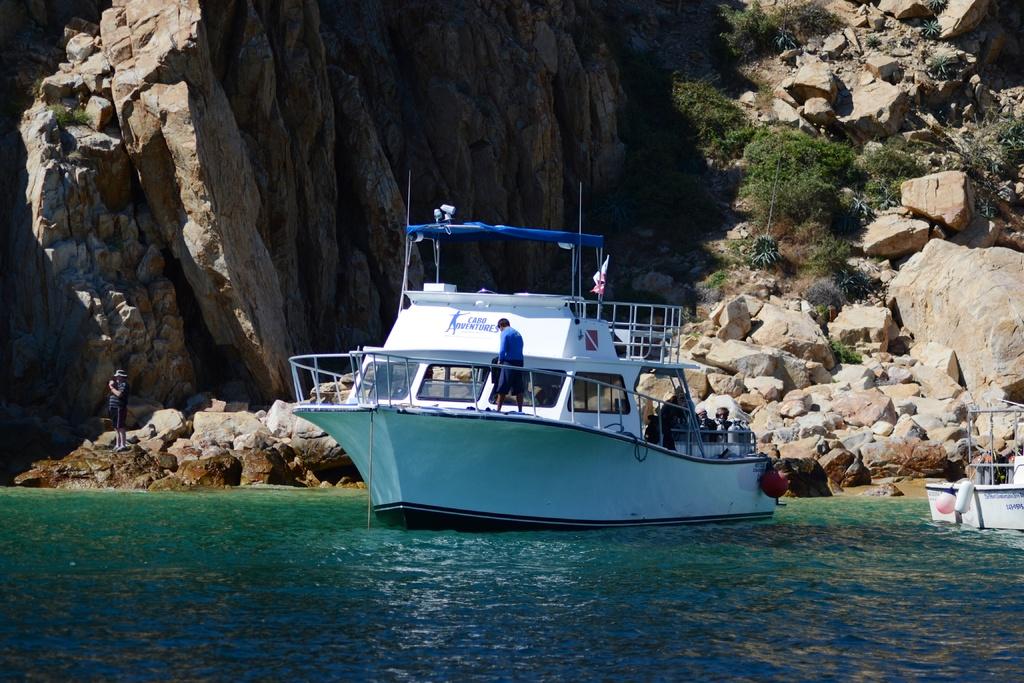What company runs the boat on the left?
Offer a very short reply. Unanswerable. 